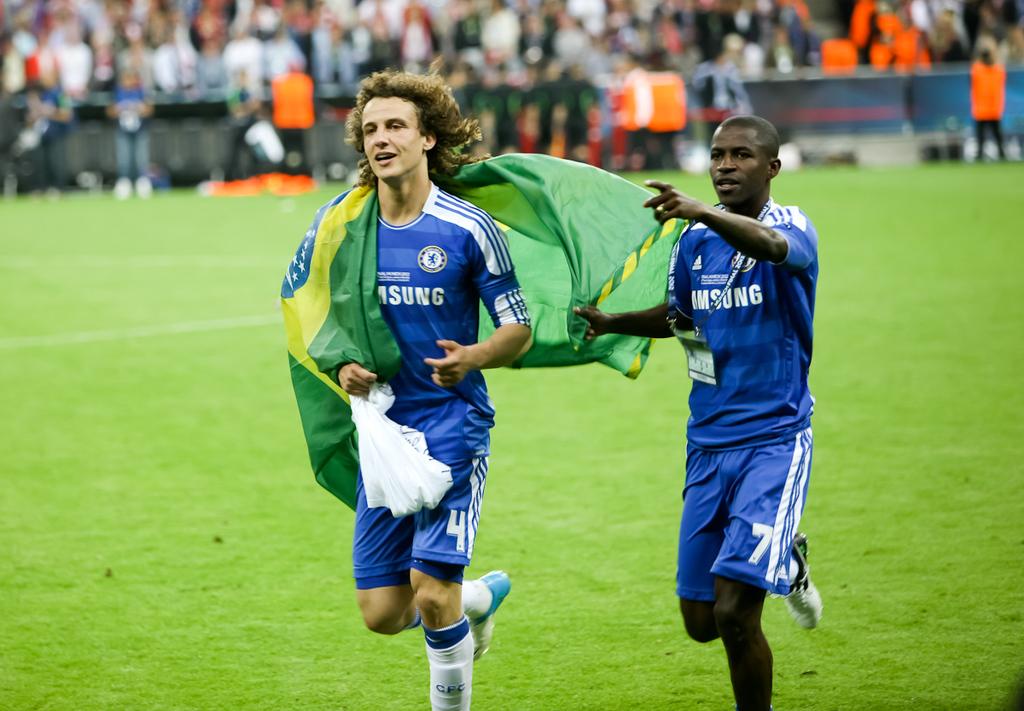What company name is on their shirts?
Ensure brevity in your answer.  Samsung. This is drinks?
Make the answer very short. Unanswerable. 